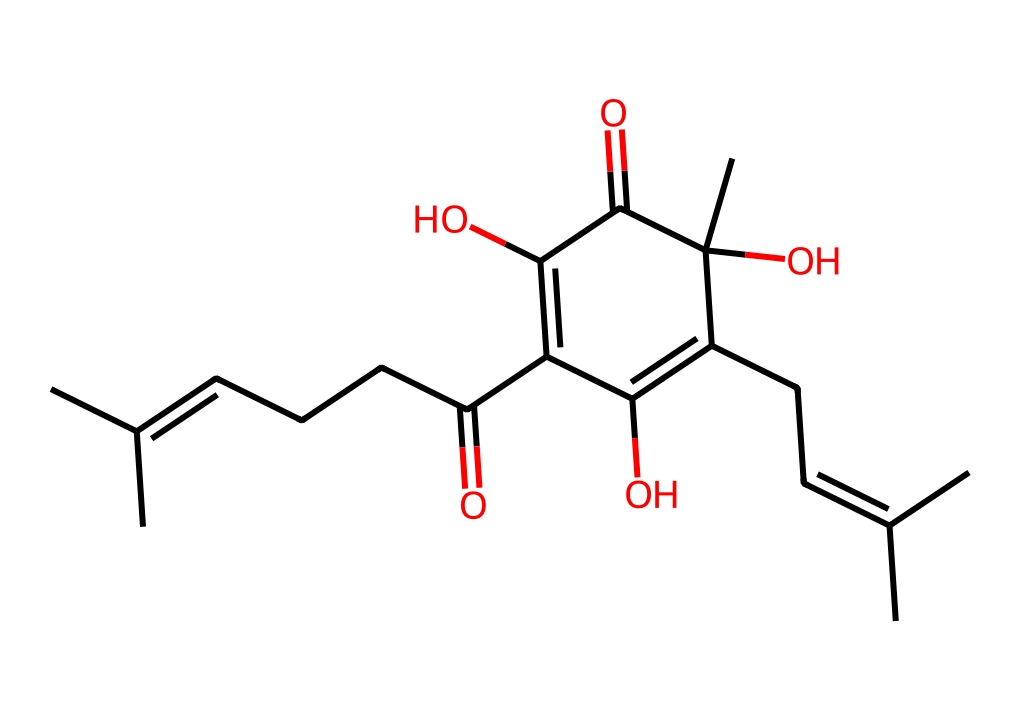How many carbon atoms are in humulone? By analyzing the SMILES representation, we can count the number of 'C's present. The SMILES indicates that there are 21 carbon atoms in total.
Answer: 21 What is the functional group present in humulone? Observing the SMILES structure, we note that the part 'C(=O)' indicates a carbonyl group (C=O), which is characteristic of ketones. Therefore, humulone contains a ketone functional group.
Answer: ketone How many hydroxyl groups are present in humulone? In the SMILES structure, we can see 'C(O)' appearing multiple times, indicating the presence of hydroxyl groups. Counting these instances shows that there are three hydroxyl groups in humulone.
Answer: 3 What type of molecule is humulone classified as? Given that humulone has a structure containing both carbonyl and hydroxyl functional groups, it fits the definition of a ketone with alcoholic character, thus making it a type of polyphenol amid a ketone.
Answer: polyphenol ketone Which part of the humulone structure contributes to its bitterness? The presence of the carbonyl group (C=O) and the specific arrangement of the hydroxyl groups and carbon chain are key to the molecule's bitter properties, commonly associated with its structure and the hops from which it is derived.
Answer: carbonyl group 